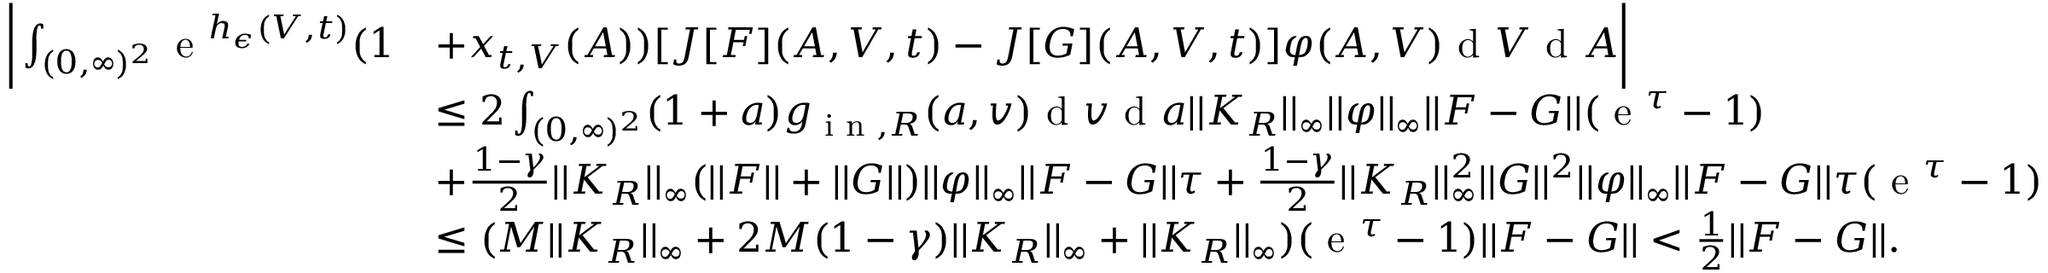Convert formula to latex. <formula><loc_0><loc_0><loc_500><loc_500>\begin{array} { r l } { \left | \int _ { ( 0 , \infty ) ^ { 2 } } e ^ { h _ { \epsilon } ( V , t ) } ( 1 } & { + x _ { t , V } ( A ) ) [ J [ F ] ( A , V , t ) - J [ G ] ( A , V , t ) ] \varphi ( A , V ) d V d A \right | } \\ & { \leq 2 \int _ { ( 0 , \infty ) ^ { 2 } } ( 1 + a ) g _ { i n , R } ( a , v ) d v d a | | K _ { R } | | _ { \infty } | | \varphi | | _ { \infty } | | F - G | | ( e ^ { \tau } - 1 ) } \\ & { + \frac { 1 - \gamma } { 2 } | | K _ { R } | | _ { \infty } ( | | F | | + | | G | | ) | | \varphi | | _ { \infty } | | F - G | | \tau + \frac { 1 - \gamma } { 2 } | | K _ { R } | | _ { \infty } ^ { 2 } | | G | | ^ { 2 } | | \varphi | | _ { \infty } | | F - G | | \tau ( e ^ { \tau } - 1 ) } \\ & { \leq ( M | | K _ { R } | | _ { \infty } + 2 M ( 1 - \gamma ) | | K _ { R } | | _ { \infty } + | | K _ { R } | | _ { \infty } ) ( e ^ { \tau } - 1 ) | | F - G | | < \frac { 1 } { 2 } | | F - G | | . } \end{array}</formula> 